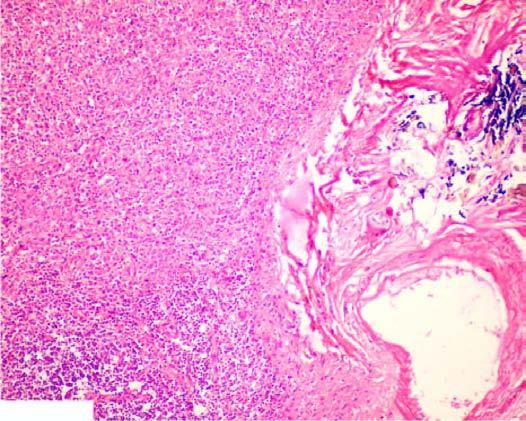re the sinuses dilated and congested?
Answer the question using a single word or phrase. Yes 